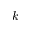<formula> <loc_0><loc_0><loc_500><loc_500>k</formula> 